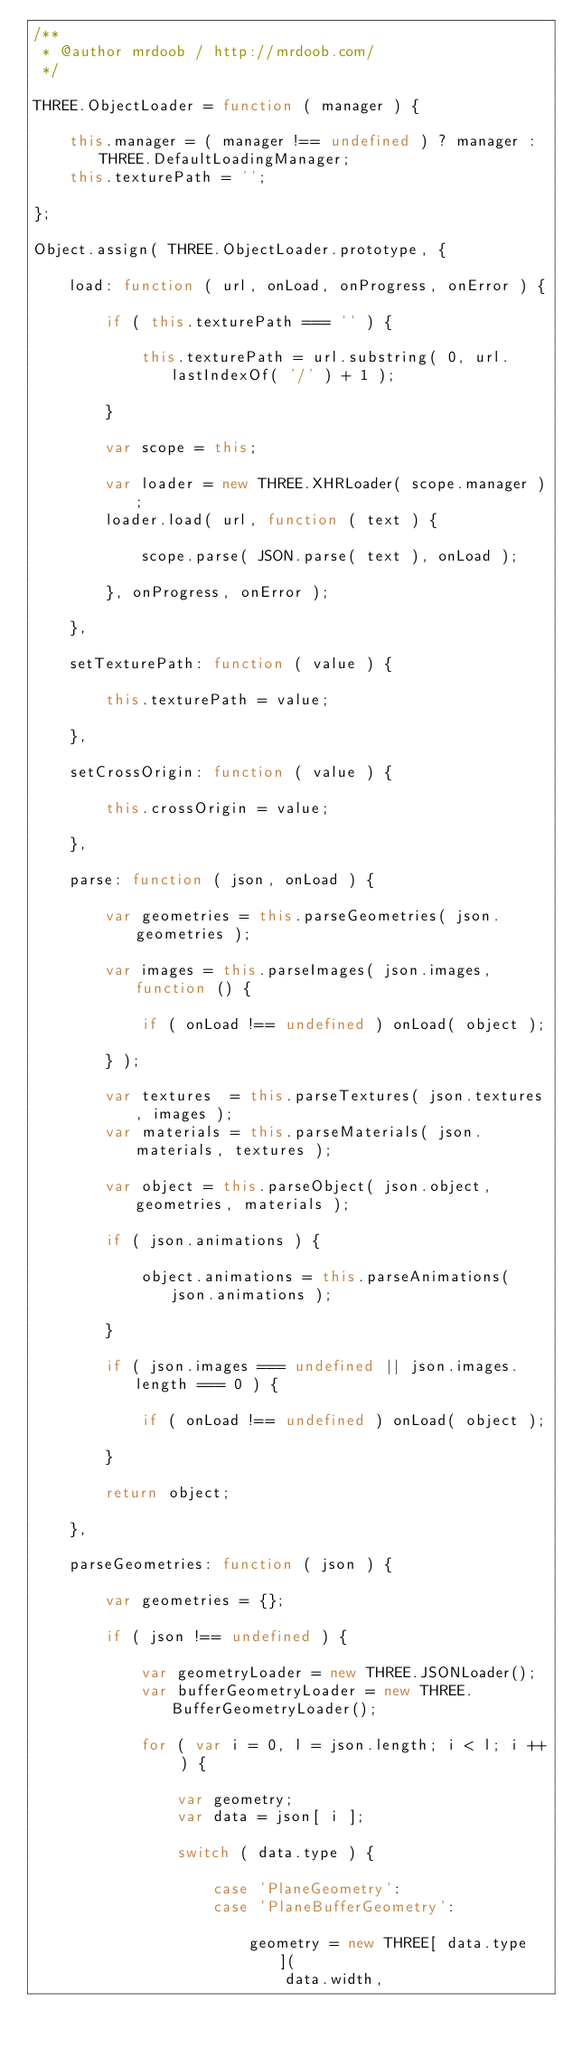Convert code to text. <code><loc_0><loc_0><loc_500><loc_500><_JavaScript_>/**
 * @author mrdoob / http://mrdoob.com/
 */

THREE.ObjectLoader = function ( manager ) {

	this.manager = ( manager !== undefined ) ? manager : THREE.DefaultLoadingManager;
	this.texturePath = '';

};

Object.assign( THREE.ObjectLoader.prototype, {

	load: function ( url, onLoad, onProgress, onError ) {

		if ( this.texturePath === '' ) {

			this.texturePath = url.substring( 0, url.lastIndexOf( '/' ) + 1 );

		}

		var scope = this;

		var loader = new THREE.XHRLoader( scope.manager );
		loader.load( url, function ( text ) {

			scope.parse( JSON.parse( text ), onLoad );

		}, onProgress, onError );

	},

	setTexturePath: function ( value ) {

		this.texturePath = value;

	},

	setCrossOrigin: function ( value ) {

		this.crossOrigin = value;

	},

	parse: function ( json, onLoad ) {

		var geometries = this.parseGeometries( json.geometries );

		var images = this.parseImages( json.images, function () {

			if ( onLoad !== undefined ) onLoad( object );

		} );

		var textures  = this.parseTextures( json.textures, images );
		var materials = this.parseMaterials( json.materials, textures );

		var object = this.parseObject( json.object, geometries, materials );

		if ( json.animations ) {

			object.animations = this.parseAnimations( json.animations );

		}

		if ( json.images === undefined || json.images.length === 0 ) {

			if ( onLoad !== undefined ) onLoad( object );

		}

		return object;

	},

	parseGeometries: function ( json ) {

		var geometries = {};

		if ( json !== undefined ) {

			var geometryLoader = new THREE.JSONLoader();
			var bufferGeometryLoader = new THREE.BufferGeometryLoader();

			for ( var i = 0, l = json.length; i < l; i ++ ) {

				var geometry;
				var data = json[ i ];

				switch ( data.type ) {

					case 'PlaneGeometry':
					case 'PlaneBufferGeometry':

						geometry = new THREE[ data.type ](
							data.width,</code> 